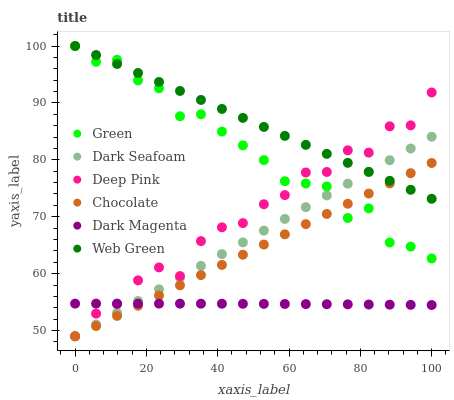Does Dark Magenta have the minimum area under the curve?
Answer yes or no. Yes. Does Web Green have the maximum area under the curve?
Answer yes or no. Yes. Does Web Green have the minimum area under the curve?
Answer yes or no. No. Does Dark Magenta have the maximum area under the curve?
Answer yes or no. No. Is Chocolate the smoothest?
Answer yes or no. Yes. Is Deep Pink the roughest?
Answer yes or no. Yes. Is Dark Magenta the smoothest?
Answer yes or no. No. Is Dark Magenta the roughest?
Answer yes or no. No. Does Deep Pink have the lowest value?
Answer yes or no. Yes. Does Dark Magenta have the lowest value?
Answer yes or no. No. Does Green have the highest value?
Answer yes or no. Yes. Does Dark Magenta have the highest value?
Answer yes or no. No. Is Dark Magenta less than Green?
Answer yes or no. Yes. Is Web Green greater than Dark Magenta?
Answer yes or no. Yes. Does Green intersect Chocolate?
Answer yes or no. Yes. Is Green less than Chocolate?
Answer yes or no. No. Is Green greater than Chocolate?
Answer yes or no. No. Does Dark Magenta intersect Green?
Answer yes or no. No. 